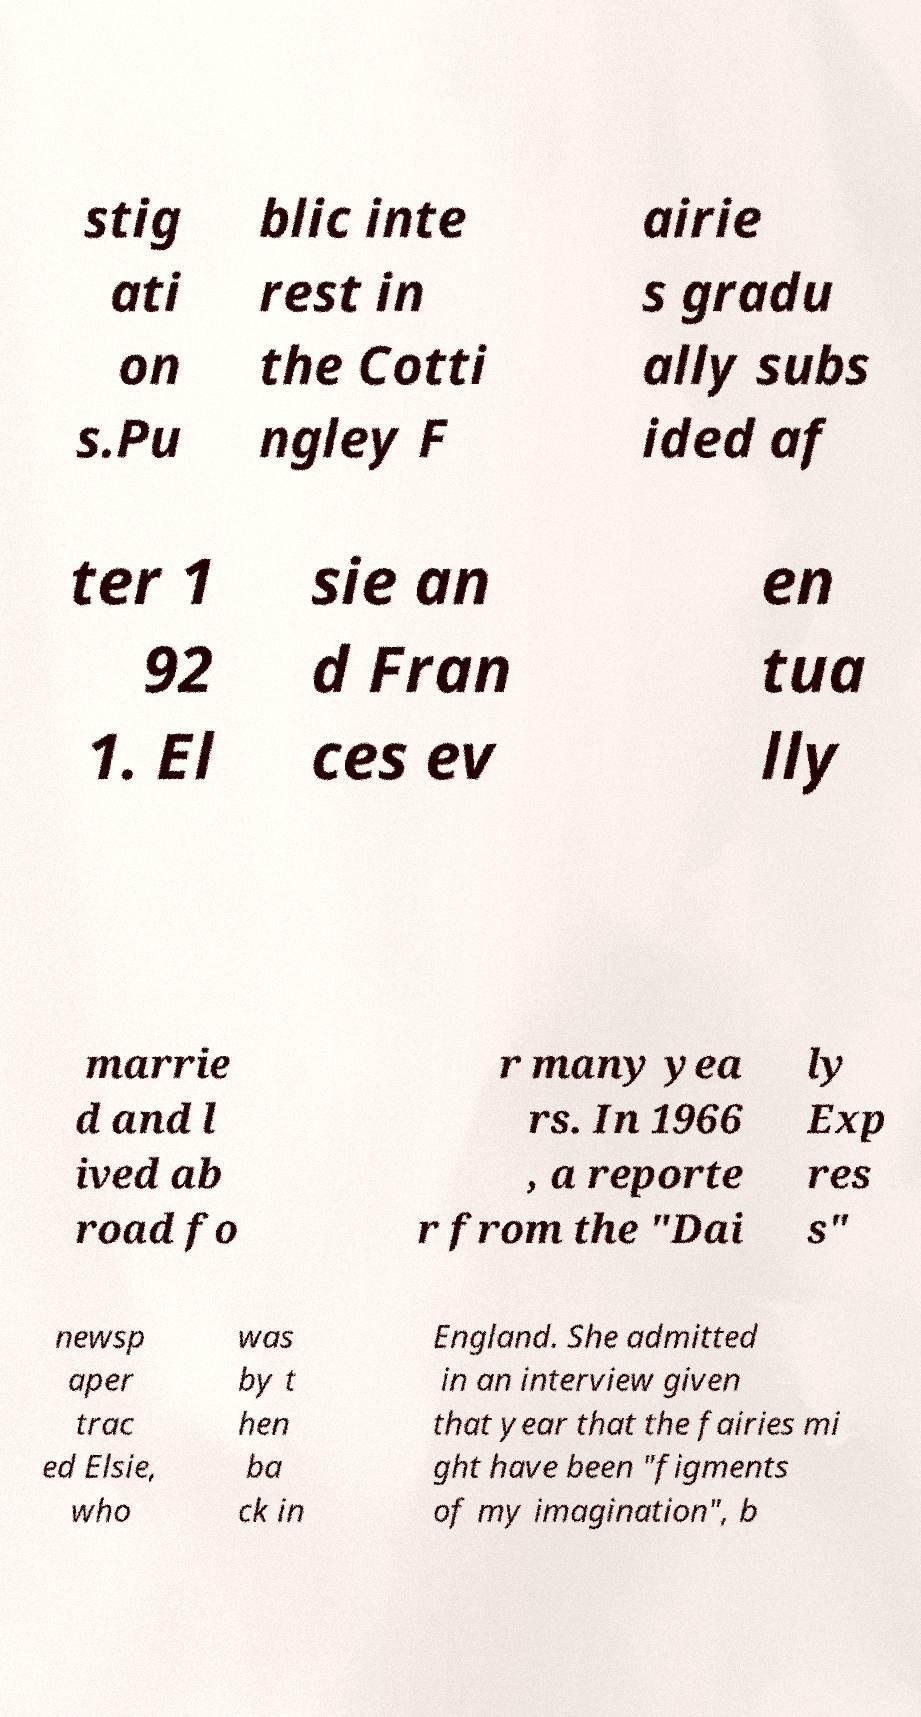Could you assist in decoding the text presented in this image and type it out clearly? stig ati on s.Pu blic inte rest in the Cotti ngley F airie s gradu ally subs ided af ter 1 92 1. El sie an d Fran ces ev en tua lly marrie d and l ived ab road fo r many yea rs. In 1966 , a reporte r from the "Dai ly Exp res s" newsp aper trac ed Elsie, who was by t hen ba ck in England. She admitted in an interview given that year that the fairies mi ght have been "figments of my imagination", b 